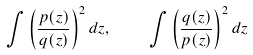Convert formula to latex. <formula><loc_0><loc_0><loc_500><loc_500>\int \left ( \frac { p ( z ) } { q ( z ) } \right ) ^ { 2 } d z , \quad \int \left ( \frac { q ( z ) } { p ( z ) } \right ) ^ { 2 } d z</formula> 